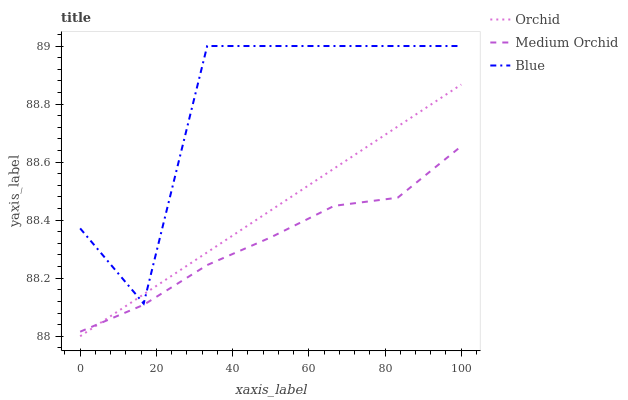Does Medium Orchid have the minimum area under the curve?
Answer yes or no. Yes. Does Blue have the maximum area under the curve?
Answer yes or no. Yes. Does Orchid have the minimum area under the curve?
Answer yes or no. No. Does Orchid have the maximum area under the curve?
Answer yes or no. No. Is Orchid the smoothest?
Answer yes or no. Yes. Is Blue the roughest?
Answer yes or no. Yes. Is Medium Orchid the smoothest?
Answer yes or no. No. Is Medium Orchid the roughest?
Answer yes or no. No. Does Orchid have the lowest value?
Answer yes or no. Yes. Does Medium Orchid have the lowest value?
Answer yes or no. No. Does Blue have the highest value?
Answer yes or no. Yes. Does Orchid have the highest value?
Answer yes or no. No. Is Medium Orchid less than Blue?
Answer yes or no. Yes. Is Blue greater than Medium Orchid?
Answer yes or no. Yes. Does Orchid intersect Blue?
Answer yes or no. Yes. Is Orchid less than Blue?
Answer yes or no. No. Is Orchid greater than Blue?
Answer yes or no. No. Does Medium Orchid intersect Blue?
Answer yes or no. No. 